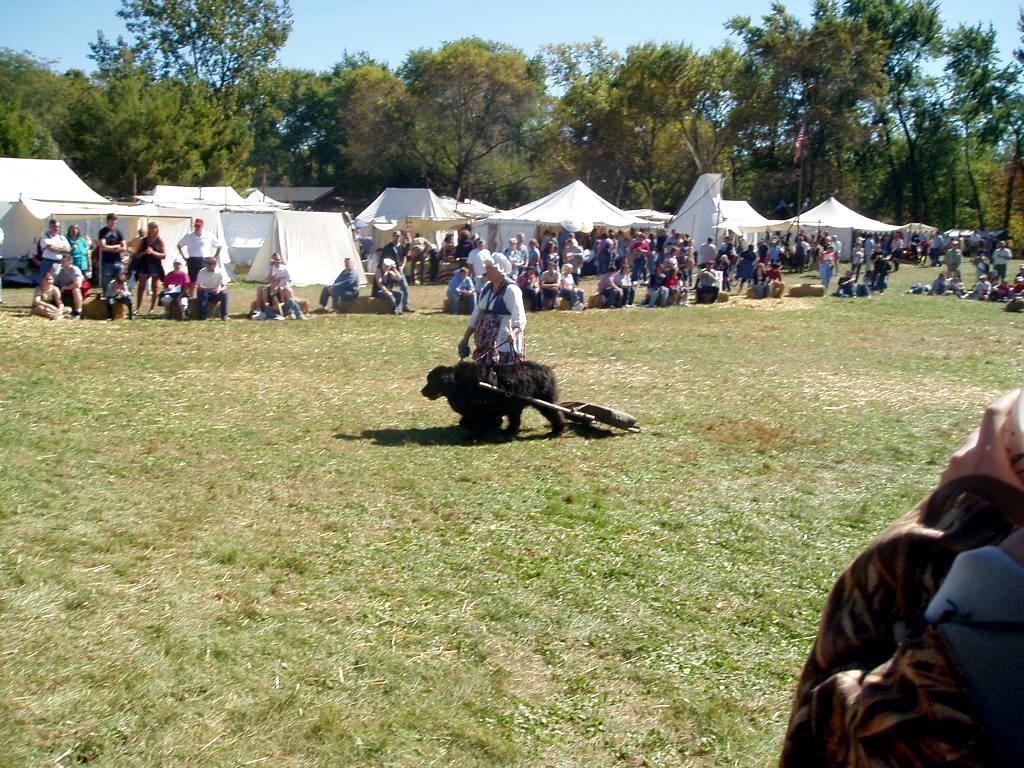Could you give a brief overview of what you see in this image? This picture shows few people seated and few are standing and we see a woman holding a dog with the help of a string and we see a dog pulling a weight on the back and we see grass on the ground and trees and few tents and we see a blue cloudy sky. 